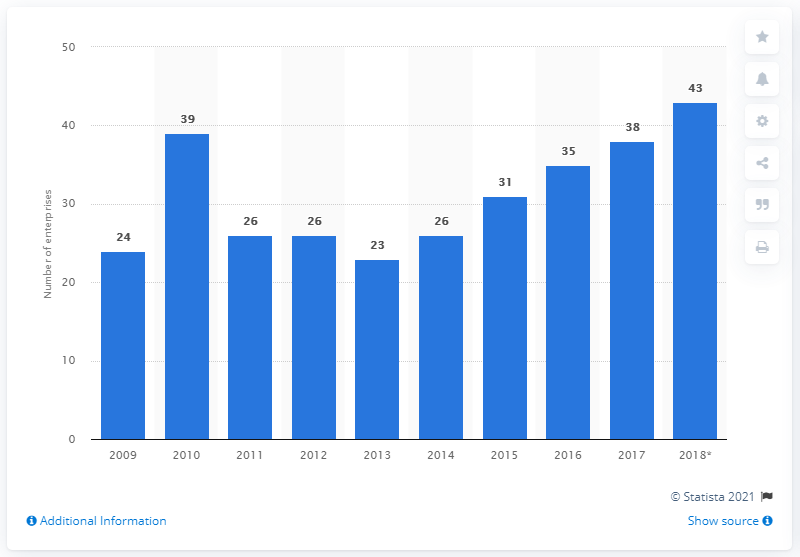Indicate a few pertinent items in this graphic. In 2018, the highest number of enterprises were registered. In 2018, there were 43 enterprises in the manufacture of soft drinks, production of mineral waters, and other bottled waters industry in Belgium. The sum of the mode and least value is 49. 